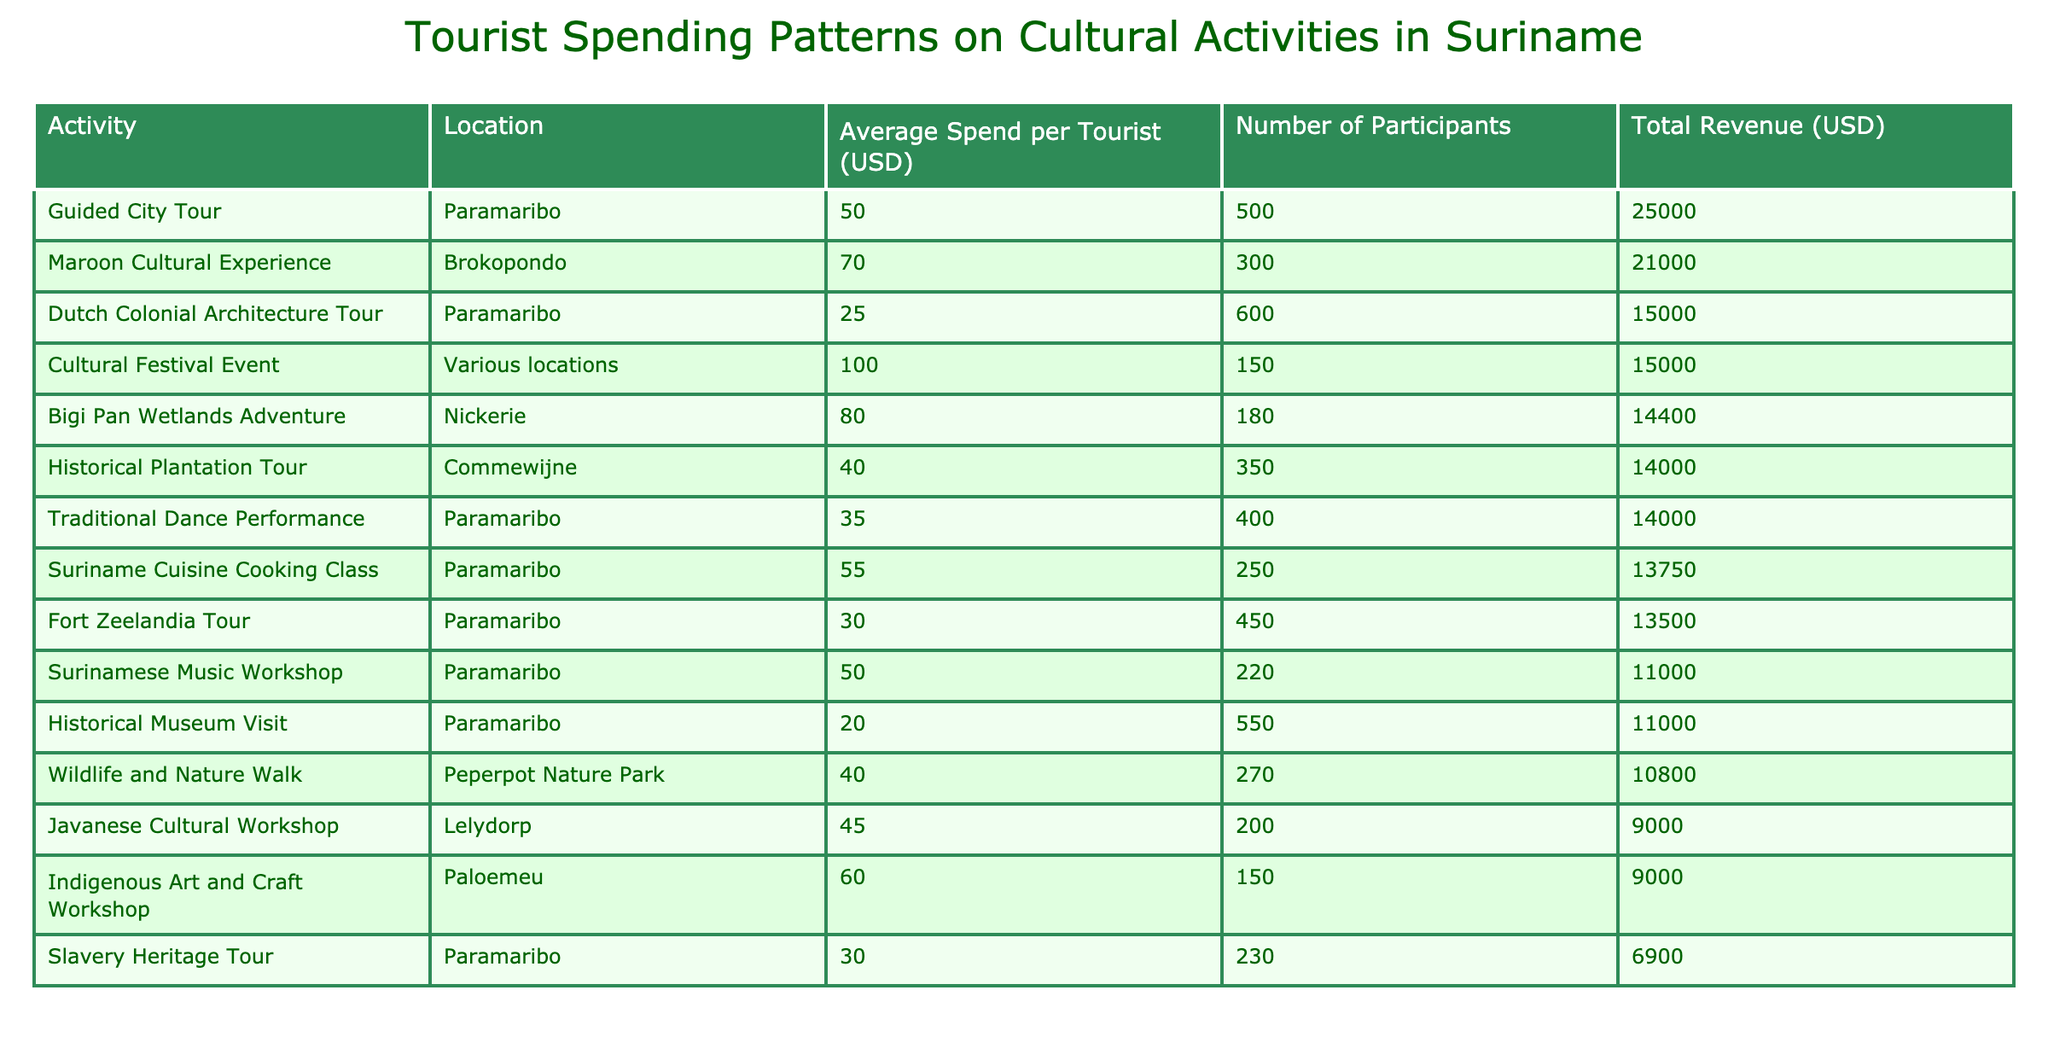What is the total revenue generated by the Guided City Tour? The total revenue for the Guided City Tour is provided in the table under the "Total Revenue (USD)" column. The value listed for this activity is 25000.
Answer: 25000 Which activity generated the highest revenue? The table shows the total revenue for each activity. By scanning through the "Total Revenue (USD)" column, we see that the activity with the highest revenue is the Guided City Tour with a total of 25000.
Answer: Guided City Tour What is the average spending per tourist for the Maroon Cultural Experience? The average spend per tourist for the Maroon Cultural Experience is listed in the "Average Spend per Tourist (USD)" column. The specific value given is 70.
Answer: 70 If you combine the total revenues for the Javanese Cultural Workshop and the Indigenous Art and Craft Workshop, what is the total? The total revenues for these workshops can be found in the "Total Revenue (USD)" column. The Javanese Cultural Workshop generates 9000, and the Indigenous Art and Craft Workshop also generates 9000. Adding these together results in 9000 + 9000 = 18000.
Answer: 18000 Is the average spend per tourist higher for the Cultural Festival Event than for the Historical Museum Visit? The average spending per tourist for the Cultural Festival Event is 100, while for the Historical Museum Visit it is 20. Since 100 is greater than 20, the statement is true.
Answer: Yes Which location has the highest number of participants, and what is that number? By looking at the "Number of Participants" column, we identify the location with the highest participant count is the Dutch Colonial Architecture Tour with 600 participants.
Answer: Dutch Colonial Architecture Tour, 600 What is the total revenue from the top three activities by revenue? To find the total revenue of the top three activities, we need to identify the three highest total revenue values from the "Total Revenue (USD)" column: Guided City Tour (25000), Maroon Cultural Experience (21000), and Bigi Pan Wetlands Adventure (14400). Summing these gives 25000 + 21000 + 14400 = 60400.
Answer: 60400 Does the average spend per tourist for the Fort Zeelandia Tour exceed 40 USD? The average spend for the Fort Zeelandia Tour is 30 USD, as listed in the "Average Spend per Tourist (USD)" column. Since 30 is less than 40, the statement is false.
Answer: No What percentage of the total participants involved in traditional dance performances is equal to the total participants in guided city tours? The number of participants in traditional dance performances is 400 and 500 in guided city tours. To find the percentage, we calculate (400/500) * 100 = 80%.
Answer: 80% 